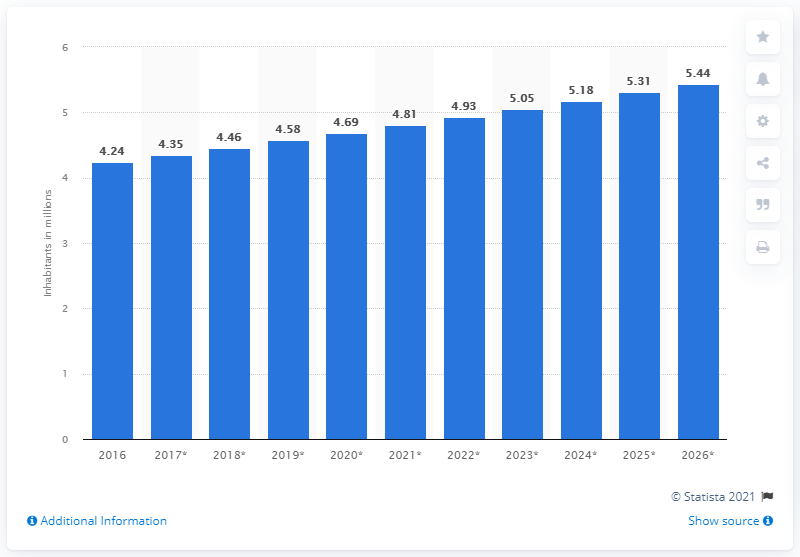Give some essential details in this illustration. In 2020, the population of Liberia was estimated to be approximately 4.69 million. 